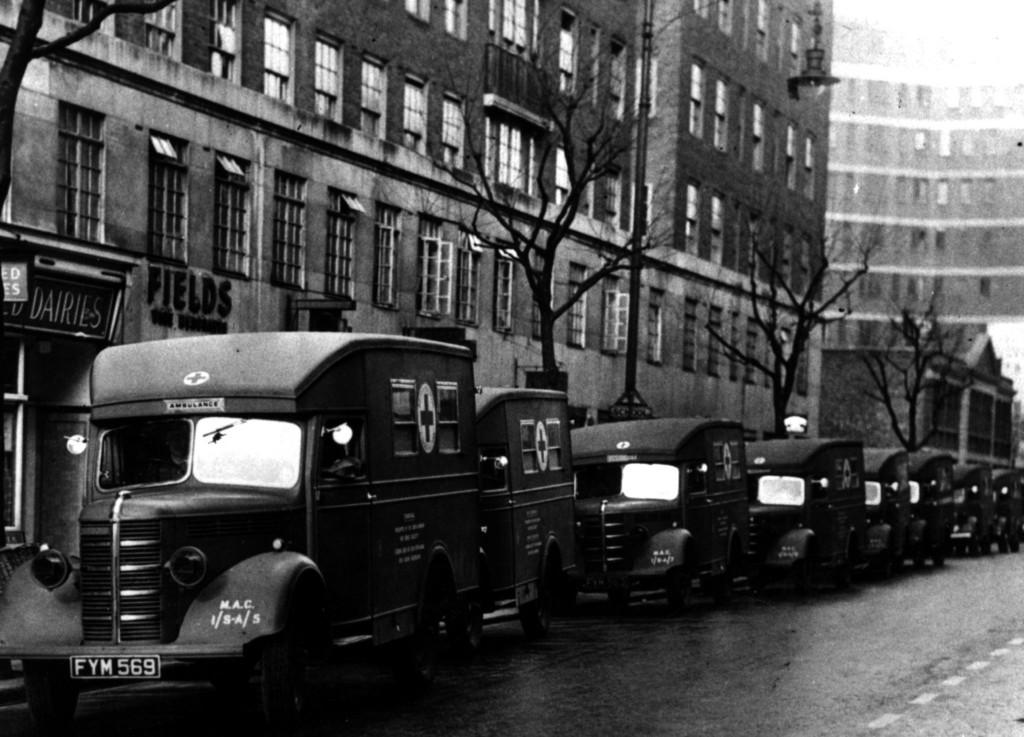What is the color scheme of the image? The image is black and white. What can be seen on the road in the image? There are vehicles on the road in the image. Where are the vehicles located in the image? The vehicles are at the bottom of the image. What is visible in the background of the image? There are trees and buildings in the background of the image. What type of egg is being used by the spy in the image? There is no spy or egg present in the image. What is the drawer used for in the image? There is no drawer present in the image. 